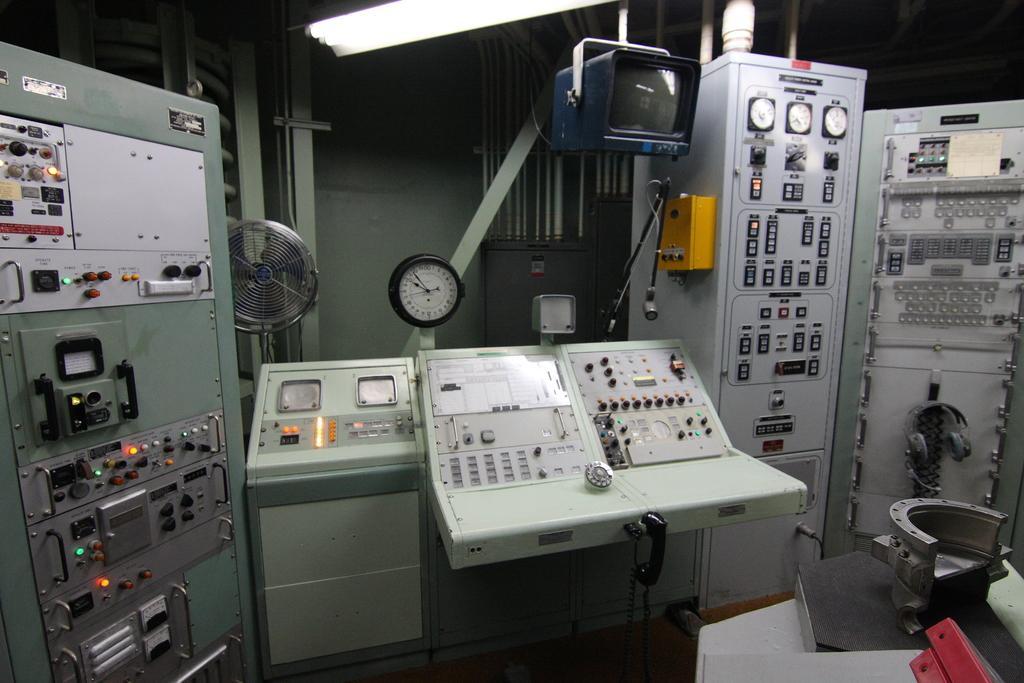Can you describe this image briefly? In this picture I can see a table fan, there is a mike with a mike stand, there is a television, headset and there are some machines. 